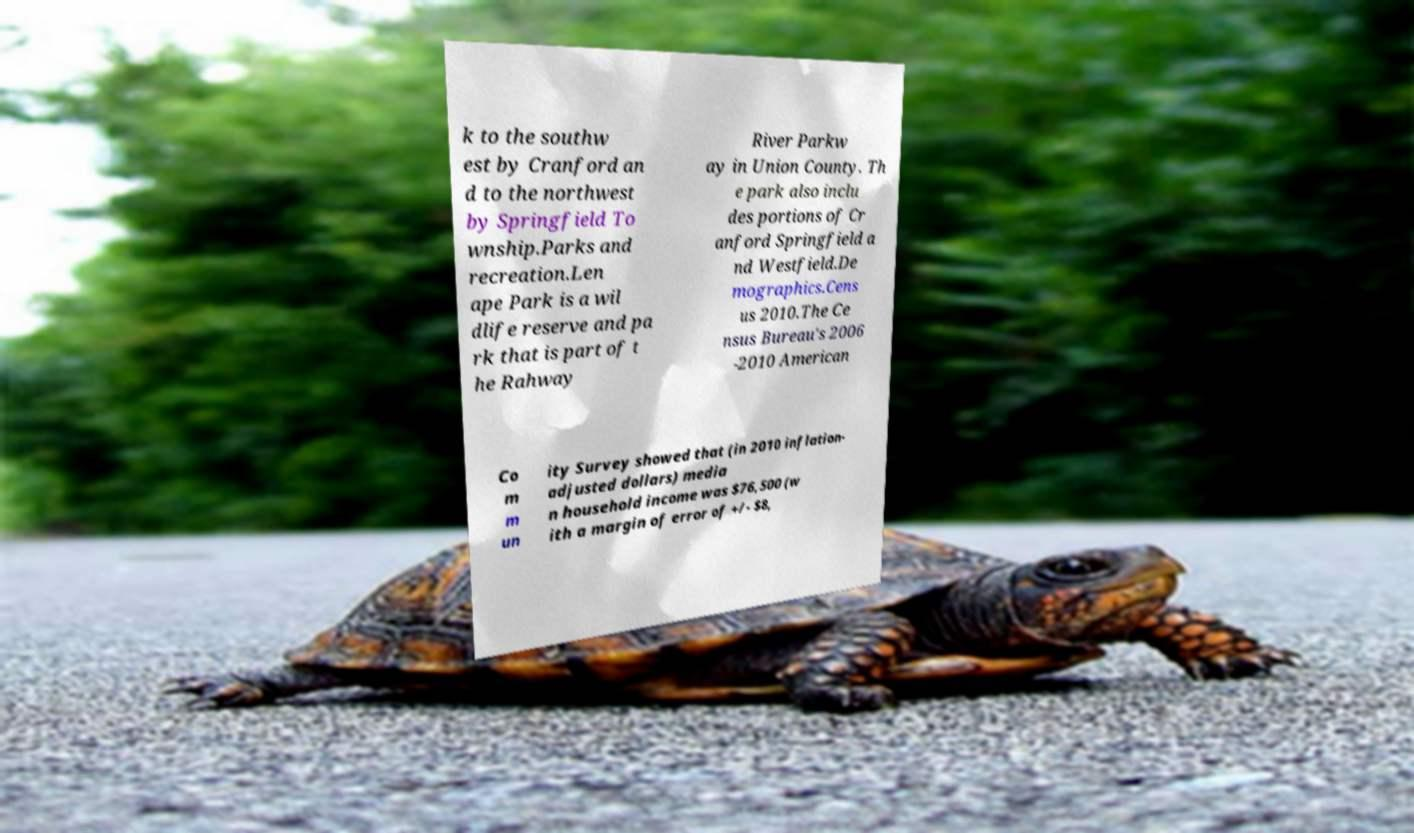For documentation purposes, I need the text within this image transcribed. Could you provide that? k to the southw est by Cranford an d to the northwest by Springfield To wnship.Parks and recreation.Len ape Park is a wil dlife reserve and pa rk that is part of t he Rahway River Parkw ay in Union County. Th e park also inclu des portions of Cr anford Springfield a nd Westfield.De mographics.Cens us 2010.The Ce nsus Bureau's 2006 -2010 American Co m m un ity Survey showed that (in 2010 inflation- adjusted dollars) media n household income was $76,500 (w ith a margin of error of +/- $8, 